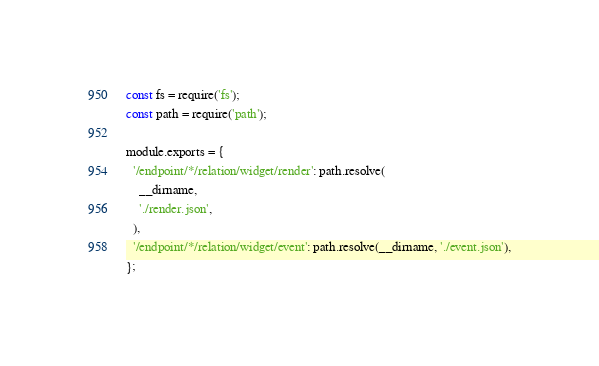<code> <loc_0><loc_0><loc_500><loc_500><_JavaScript_>const fs = require('fs');
const path = require('path');

module.exports = {
  '/endpoint/*/relation/widget/render': path.resolve(
    __dirname,
    './render.json',
  ),
  '/endpoint/*/relation/widget/event': path.resolve(__dirname, './event.json'),
};
</code> 